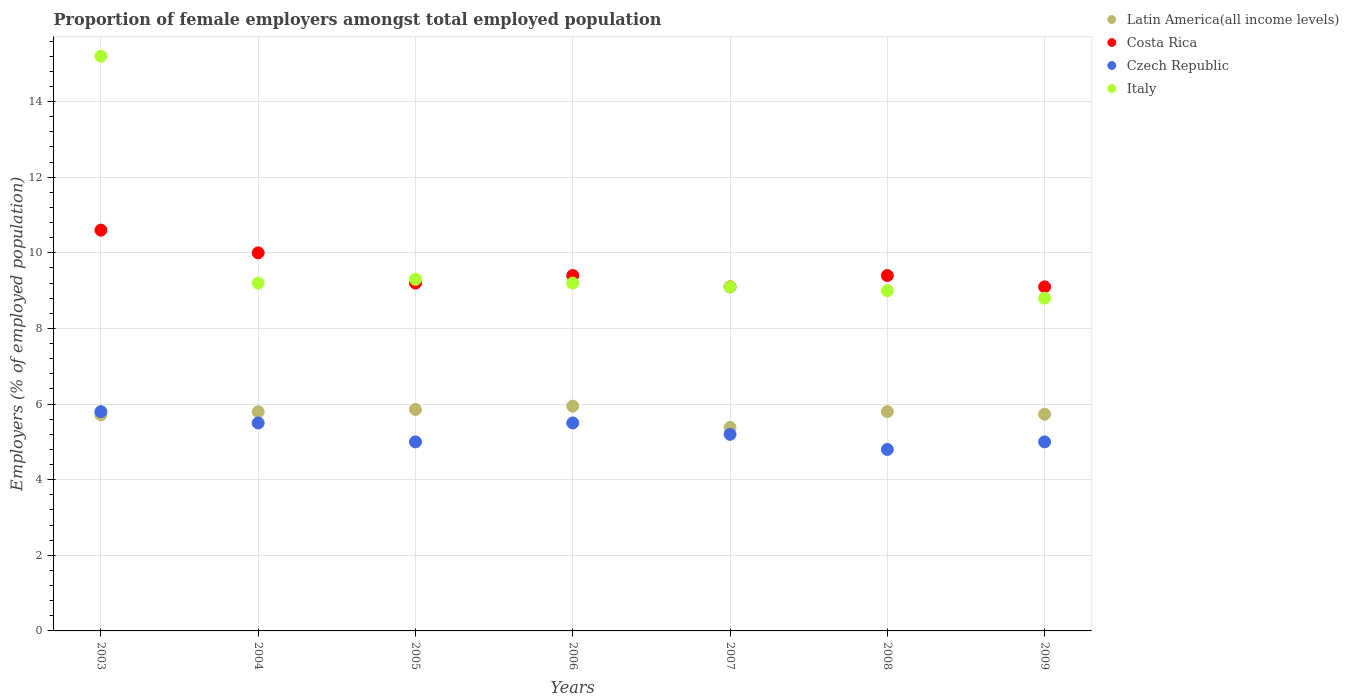How many different coloured dotlines are there?
Your answer should be compact. 4. Across all years, what is the maximum proportion of female employers in Czech Republic?
Offer a terse response. 5.8. Across all years, what is the minimum proportion of female employers in Costa Rica?
Your response must be concise. 9.1. In which year was the proportion of female employers in Costa Rica maximum?
Offer a terse response. 2003. In which year was the proportion of female employers in Latin America(all income levels) minimum?
Offer a very short reply. 2007. What is the total proportion of female employers in Costa Rica in the graph?
Offer a terse response. 66.8. What is the difference between the proportion of female employers in Costa Rica in 2006 and that in 2008?
Provide a short and direct response. 0. What is the difference between the proportion of female employers in Italy in 2004 and the proportion of female employers in Czech Republic in 2008?
Offer a very short reply. 4.4. What is the average proportion of female employers in Czech Republic per year?
Offer a terse response. 5.26. In the year 2007, what is the difference between the proportion of female employers in Italy and proportion of female employers in Costa Rica?
Give a very brief answer. 0. In how many years, is the proportion of female employers in Italy greater than 2.4 %?
Make the answer very short. 7. What is the ratio of the proportion of female employers in Latin America(all income levels) in 2004 to that in 2009?
Keep it short and to the point. 1.01. Is the proportion of female employers in Czech Republic in 2003 less than that in 2004?
Give a very brief answer. No. Is the difference between the proportion of female employers in Italy in 2004 and 2005 greater than the difference between the proportion of female employers in Costa Rica in 2004 and 2005?
Offer a very short reply. No. What is the difference between the highest and the second highest proportion of female employers in Italy?
Keep it short and to the point. 5.9. What is the difference between the highest and the lowest proportion of female employers in Costa Rica?
Ensure brevity in your answer.  1.5. In how many years, is the proportion of female employers in Italy greater than the average proportion of female employers in Italy taken over all years?
Ensure brevity in your answer.  1. Is the sum of the proportion of female employers in Costa Rica in 2004 and 2009 greater than the maximum proportion of female employers in Latin America(all income levels) across all years?
Make the answer very short. Yes. Is it the case that in every year, the sum of the proportion of female employers in Latin America(all income levels) and proportion of female employers in Czech Republic  is greater than the sum of proportion of female employers in Italy and proportion of female employers in Costa Rica?
Provide a short and direct response. No. Is it the case that in every year, the sum of the proportion of female employers in Latin America(all income levels) and proportion of female employers in Czech Republic  is greater than the proportion of female employers in Costa Rica?
Offer a terse response. Yes. Does the proportion of female employers in Italy monotonically increase over the years?
Offer a terse response. No. Is the proportion of female employers in Italy strictly greater than the proportion of female employers in Costa Rica over the years?
Offer a terse response. No. What is the difference between two consecutive major ticks on the Y-axis?
Offer a terse response. 2. Does the graph contain grids?
Make the answer very short. Yes. Where does the legend appear in the graph?
Give a very brief answer. Top right. What is the title of the graph?
Give a very brief answer. Proportion of female employers amongst total employed population. What is the label or title of the X-axis?
Your answer should be very brief. Years. What is the label or title of the Y-axis?
Ensure brevity in your answer.  Employers (% of employed population). What is the Employers (% of employed population) in Latin America(all income levels) in 2003?
Keep it short and to the point. 5.72. What is the Employers (% of employed population) in Costa Rica in 2003?
Your response must be concise. 10.6. What is the Employers (% of employed population) of Czech Republic in 2003?
Your answer should be very brief. 5.8. What is the Employers (% of employed population) in Italy in 2003?
Offer a very short reply. 15.2. What is the Employers (% of employed population) in Latin America(all income levels) in 2004?
Provide a short and direct response. 5.8. What is the Employers (% of employed population) in Costa Rica in 2004?
Offer a very short reply. 10. What is the Employers (% of employed population) in Italy in 2004?
Provide a short and direct response. 9.2. What is the Employers (% of employed population) of Latin America(all income levels) in 2005?
Offer a very short reply. 5.86. What is the Employers (% of employed population) in Costa Rica in 2005?
Your answer should be very brief. 9.2. What is the Employers (% of employed population) in Italy in 2005?
Your response must be concise. 9.3. What is the Employers (% of employed population) in Latin America(all income levels) in 2006?
Your answer should be compact. 5.95. What is the Employers (% of employed population) in Costa Rica in 2006?
Your response must be concise. 9.4. What is the Employers (% of employed population) of Czech Republic in 2006?
Give a very brief answer. 5.5. What is the Employers (% of employed population) of Italy in 2006?
Offer a terse response. 9.2. What is the Employers (% of employed population) in Latin America(all income levels) in 2007?
Your answer should be very brief. 5.38. What is the Employers (% of employed population) of Costa Rica in 2007?
Offer a very short reply. 9.1. What is the Employers (% of employed population) of Czech Republic in 2007?
Your response must be concise. 5.2. What is the Employers (% of employed population) in Italy in 2007?
Your answer should be very brief. 9.1. What is the Employers (% of employed population) in Latin America(all income levels) in 2008?
Provide a succinct answer. 5.8. What is the Employers (% of employed population) in Costa Rica in 2008?
Your answer should be very brief. 9.4. What is the Employers (% of employed population) in Czech Republic in 2008?
Offer a terse response. 4.8. What is the Employers (% of employed population) in Latin America(all income levels) in 2009?
Make the answer very short. 5.73. What is the Employers (% of employed population) in Costa Rica in 2009?
Make the answer very short. 9.1. What is the Employers (% of employed population) of Italy in 2009?
Offer a terse response. 8.8. Across all years, what is the maximum Employers (% of employed population) of Latin America(all income levels)?
Keep it short and to the point. 5.95. Across all years, what is the maximum Employers (% of employed population) in Costa Rica?
Your answer should be very brief. 10.6. Across all years, what is the maximum Employers (% of employed population) in Czech Republic?
Your answer should be very brief. 5.8. Across all years, what is the maximum Employers (% of employed population) in Italy?
Offer a terse response. 15.2. Across all years, what is the minimum Employers (% of employed population) of Latin America(all income levels)?
Keep it short and to the point. 5.38. Across all years, what is the minimum Employers (% of employed population) in Costa Rica?
Your answer should be compact. 9.1. Across all years, what is the minimum Employers (% of employed population) of Czech Republic?
Give a very brief answer. 4.8. Across all years, what is the minimum Employers (% of employed population) in Italy?
Your answer should be very brief. 8.8. What is the total Employers (% of employed population) in Latin America(all income levels) in the graph?
Offer a very short reply. 40.23. What is the total Employers (% of employed population) in Costa Rica in the graph?
Your response must be concise. 66.8. What is the total Employers (% of employed population) in Czech Republic in the graph?
Your answer should be compact. 36.8. What is the total Employers (% of employed population) of Italy in the graph?
Offer a very short reply. 69.8. What is the difference between the Employers (% of employed population) of Latin America(all income levels) in 2003 and that in 2004?
Ensure brevity in your answer.  -0.08. What is the difference between the Employers (% of employed population) in Costa Rica in 2003 and that in 2004?
Your answer should be compact. 0.6. What is the difference between the Employers (% of employed population) in Latin America(all income levels) in 2003 and that in 2005?
Keep it short and to the point. -0.14. What is the difference between the Employers (% of employed population) in Italy in 2003 and that in 2005?
Make the answer very short. 5.9. What is the difference between the Employers (% of employed population) in Latin America(all income levels) in 2003 and that in 2006?
Your response must be concise. -0.23. What is the difference between the Employers (% of employed population) in Latin America(all income levels) in 2003 and that in 2007?
Your response must be concise. 0.33. What is the difference between the Employers (% of employed population) of Costa Rica in 2003 and that in 2007?
Ensure brevity in your answer.  1.5. What is the difference between the Employers (% of employed population) in Czech Republic in 2003 and that in 2007?
Provide a succinct answer. 0.6. What is the difference between the Employers (% of employed population) of Italy in 2003 and that in 2007?
Give a very brief answer. 6.1. What is the difference between the Employers (% of employed population) of Latin America(all income levels) in 2003 and that in 2008?
Give a very brief answer. -0.08. What is the difference between the Employers (% of employed population) in Czech Republic in 2003 and that in 2008?
Make the answer very short. 1. What is the difference between the Employers (% of employed population) in Italy in 2003 and that in 2008?
Provide a succinct answer. 6.2. What is the difference between the Employers (% of employed population) of Latin America(all income levels) in 2003 and that in 2009?
Offer a very short reply. -0.02. What is the difference between the Employers (% of employed population) of Costa Rica in 2003 and that in 2009?
Your answer should be compact. 1.5. What is the difference between the Employers (% of employed population) of Latin America(all income levels) in 2004 and that in 2005?
Your response must be concise. -0.06. What is the difference between the Employers (% of employed population) of Costa Rica in 2004 and that in 2005?
Keep it short and to the point. 0.8. What is the difference between the Employers (% of employed population) in Latin America(all income levels) in 2004 and that in 2006?
Make the answer very short. -0.15. What is the difference between the Employers (% of employed population) of Costa Rica in 2004 and that in 2006?
Ensure brevity in your answer.  0.6. What is the difference between the Employers (% of employed population) in Latin America(all income levels) in 2004 and that in 2007?
Your answer should be compact. 0.41. What is the difference between the Employers (% of employed population) of Costa Rica in 2004 and that in 2007?
Offer a terse response. 0.9. What is the difference between the Employers (% of employed population) of Latin America(all income levels) in 2004 and that in 2008?
Make the answer very short. -0. What is the difference between the Employers (% of employed population) in Czech Republic in 2004 and that in 2008?
Provide a succinct answer. 0.7. What is the difference between the Employers (% of employed population) in Italy in 2004 and that in 2008?
Ensure brevity in your answer.  0.2. What is the difference between the Employers (% of employed population) of Latin America(all income levels) in 2004 and that in 2009?
Keep it short and to the point. 0.06. What is the difference between the Employers (% of employed population) of Latin America(all income levels) in 2005 and that in 2006?
Give a very brief answer. -0.09. What is the difference between the Employers (% of employed population) in Costa Rica in 2005 and that in 2006?
Offer a very short reply. -0.2. What is the difference between the Employers (% of employed population) in Czech Republic in 2005 and that in 2006?
Ensure brevity in your answer.  -0.5. What is the difference between the Employers (% of employed population) in Italy in 2005 and that in 2006?
Offer a very short reply. 0.1. What is the difference between the Employers (% of employed population) in Latin America(all income levels) in 2005 and that in 2007?
Ensure brevity in your answer.  0.48. What is the difference between the Employers (% of employed population) of Czech Republic in 2005 and that in 2007?
Your answer should be very brief. -0.2. What is the difference between the Employers (% of employed population) of Latin America(all income levels) in 2005 and that in 2008?
Give a very brief answer. 0.06. What is the difference between the Employers (% of employed population) of Costa Rica in 2005 and that in 2008?
Provide a succinct answer. -0.2. What is the difference between the Employers (% of employed population) in Latin America(all income levels) in 2005 and that in 2009?
Make the answer very short. 0.13. What is the difference between the Employers (% of employed population) in Costa Rica in 2005 and that in 2009?
Offer a terse response. 0.1. What is the difference between the Employers (% of employed population) of Latin America(all income levels) in 2006 and that in 2007?
Give a very brief answer. 0.56. What is the difference between the Employers (% of employed population) in Latin America(all income levels) in 2006 and that in 2008?
Offer a very short reply. 0.14. What is the difference between the Employers (% of employed population) in Costa Rica in 2006 and that in 2008?
Offer a very short reply. 0. What is the difference between the Employers (% of employed population) of Czech Republic in 2006 and that in 2008?
Ensure brevity in your answer.  0.7. What is the difference between the Employers (% of employed population) of Italy in 2006 and that in 2008?
Provide a succinct answer. 0.2. What is the difference between the Employers (% of employed population) in Latin America(all income levels) in 2006 and that in 2009?
Provide a short and direct response. 0.21. What is the difference between the Employers (% of employed population) of Costa Rica in 2006 and that in 2009?
Offer a very short reply. 0.3. What is the difference between the Employers (% of employed population) of Czech Republic in 2006 and that in 2009?
Make the answer very short. 0.5. What is the difference between the Employers (% of employed population) in Italy in 2006 and that in 2009?
Your answer should be very brief. 0.4. What is the difference between the Employers (% of employed population) in Latin America(all income levels) in 2007 and that in 2008?
Make the answer very short. -0.42. What is the difference between the Employers (% of employed population) in Latin America(all income levels) in 2007 and that in 2009?
Make the answer very short. -0.35. What is the difference between the Employers (% of employed population) in Italy in 2007 and that in 2009?
Your response must be concise. 0.3. What is the difference between the Employers (% of employed population) of Latin America(all income levels) in 2008 and that in 2009?
Provide a short and direct response. 0.07. What is the difference between the Employers (% of employed population) in Costa Rica in 2008 and that in 2009?
Give a very brief answer. 0.3. What is the difference between the Employers (% of employed population) of Czech Republic in 2008 and that in 2009?
Ensure brevity in your answer.  -0.2. What is the difference between the Employers (% of employed population) in Italy in 2008 and that in 2009?
Provide a succinct answer. 0.2. What is the difference between the Employers (% of employed population) in Latin America(all income levels) in 2003 and the Employers (% of employed population) in Costa Rica in 2004?
Offer a very short reply. -4.28. What is the difference between the Employers (% of employed population) of Latin America(all income levels) in 2003 and the Employers (% of employed population) of Czech Republic in 2004?
Ensure brevity in your answer.  0.22. What is the difference between the Employers (% of employed population) in Latin America(all income levels) in 2003 and the Employers (% of employed population) in Italy in 2004?
Keep it short and to the point. -3.48. What is the difference between the Employers (% of employed population) of Costa Rica in 2003 and the Employers (% of employed population) of Italy in 2004?
Offer a terse response. 1.4. What is the difference between the Employers (% of employed population) of Latin America(all income levels) in 2003 and the Employers (% of employed population) of Costa Rica in 2005?
Your response must be concise. -3.48. What is the difference between the Employers (% of employed population) of Latin America(all income levels) in 2003 and the Employers (% of employed population) of Czech Republic in 2005?
Offer a terse response. 0.72. What is the difference between the Employers (% of employed population) of Latin America(all income levels) in 2003 and the Employers (% of employed population) of Italy in 2005?
Your response must be concise. -3.58. What is the difference between the Employers (% of employed population) of Czech Republic in 2003 and the Employers (% of employed population) of Italy in 2005?
Offer a very short reply. -3.5. What is the difference between the Employers (% of employed population) of Latin America(all income levels) in 2003 and the Employers (% of employed population) of Costa Rica in 2006?
Give a very brief answer. -3.68. What is the difference between the Employers (% of employed population) of Latin America(all income levels) in 2003 and the Employers (% of employed population) of Czech Republic in 2006?
Make the answer very short. 0.22. What is the difference between the Employers (% of employed population) in Latin America(all income levels) in 2003 and the Employers (% of employed population) in Italy in 2006?
Your response must be concise. -3.48. What is the difference between the Employers (% of employed population) in Costa Rica in 2003 and the Employers (% of employed population) in Czech Republic in 2006?
Provide a succinct answer. 5.1. What is the difference between the Employers (% of employed population) of Latin America(all income levels) in 2003 and the Employers (% of employed population) of Costa Rica in 2007?
Make the answer very short. -3.38. What is the difference between the Employers (% of employed population) of Latin America(all income levels) in 2003 and the Employers (% of employed population) of Czech Republic in 2007?
Your answer should be compact. 0.52. What is the difference between the Employers (% of employed population) of Latin America(all income levels) in 2003 and the Employers (% of employed population) of Italy in 2007?
Ensure brevity in your answer.  -3.38. What is the difference between the Employers (% of employed population) in Costa Rica in 2003 and the Employers (% of employed population) in Czech Republic in 2007?
Provide a short and direct response. 5.4. What is the difference between the Employers (% of employed population) of Latin America(all income levels) in 2003 and the Employers (% of employed population) of Costa Rica in 2008?
Ensure brevity in your answer.  -3.68. What is the difference between the Employers (% of employed population) in Latin America(all income levels) in 2003 and the Employers (% of employed population) in Czech Republic in 2008?
Offer a terse response. 0.92. What is the difference between the Employers (% of employed population) of Latin America(all income levels) in 2003 and the Employers (% of employed population) of Italy in 2008?
Your answer should be compact. -3.28. What is the difference between the Employers (% of employed population) in Costa Rica in 2003 and the Employers (% of employed population) in Italy in 2008?
Offer a terse response. 1.6. What is the difference between the Employers (% of employed population) of Czech Republic in 2003 and the Employers (% of employed population) of Italy in 2008?
Provide a succinct answer. -3.2. What is the difference between the Employers (% of employed population) in Latin America(all income levels) in 2003 and the Employers (% of employed population) in Costa Rica in 2009?
Your answer should be compact. -3.38. What is the difference between the Employers (% of employed population) of Latin America(all income levels) in 2003 and the Employers (% of employed population) of Czech Republic in 2009?
Give a very brief answer. 0.72. What is the difference between the Employers (% of employed population) in Latin America(all income levels) in 2003 and the Employers (% of employed population) in Italy in 2009?
Provide a succinct answer. -3.08. What is the difference between the Employers (% of employed population) in Costa Rica in 2003 and the Employers (% of employed population) in Italy in 2009?
Provide a short and direct response. 1.8. What is the difference between the Employers (% of employed population) in Latin America(all income levels) in 2004 and the Employers (% of employed population) in Costa Rica in 2005?
Offer a very short reply. -3.4. What is the difference between the Employers (% of employed population) in Latin America(all income levels) in 2004 and the Employers (% of employed population) in Czech Republic in 2005?
Keep it short and to the point. 0.8. What is the difference between the Employers (% of employed population) in Latin America(all income levels) in 2004 and the Employers (% of employed population) in Italy in 2005?
Keep it short and to the point. -3.5. What is the difference between the Employers (% of employed population) in Czech Republic in 2004 and the Employers (% of employed population) in Italy in 2005?
Ensure brevity in your answer.  -3.8. What is the difference between the Employers (% of employed population) in Latin America(all income levels) in 2004 and the Employers (% of employed population) in Costa Rica in 2006?
Offer a terse response. -3.6. What is the difference between the Employers (% of employed population) of Latin America(all income levels) in 2004 and the Employers (% of employed population) of Czech Republic in 2006?
Keep it short and to the point. 0.3. What is the difference between the Employers (% of employed population) in Latin America(all income levels) in 2004 and the Employers (% of employed population) in Italy in 2006?
Offer a very short reply. -3.4. What is the difference between the Employers (% of employed population) in Latin America(all income levels) in 2004 and the Employers (% of employed population) in Costa Rica in 2007?
Offer a very short reply. -3.3. What is the difference between the Employers (% of employed population) in Latin America(all income levels) in 2004 and the Employers (% of employed population) in Czech Republic in 2007?
Ensure brevity in your answer.  0.6. What is the difference between the Employers (% of employed population) of Latin America(all income levels) in 2004 and the Employers (% of employed population) of Italy in 2007?
Offer a very short reply. -3.3. What is the difference between the Employers (% of employed population) of Costa Rica in 2004 and the Employers (% of employed population) of Italy in 2007?
Provide a succinct answer. 0.9. What is the difference between the Employers (% of employed population) in Latin America(all income levels) in 2004 and the Employers (% of employed population) in Costa Rica in 2008?
Your answer should be compact. -3.6. What is the difference between the Employers (% of employed population) of Latin America(all income levels) in 2004 and the Employers (% of employed population) of Italy in 2008?
Offer a terse response. -3.2. What is the difference between the Employers (% of employed population) of Costa Rica in 2004 and the Employers (% of employed population) of Italy in 2008?
Your response must be concise. 1. What is the difference between the Employers (% of employed population) of Czech Republic in 2004 and the Employers (% of employed population) of Italy in 2008?
Keep it short and to the point. -3.5. What is the difference between the Employers (% of employed population) in Latin America(all income levels) in 2004 and the Employers (% of employed population) in Costa Rica in 2009?
Ensure brevity in your answer.  -3.3. What is the difference between the Employers (% of employed population) in Latin America(all income levels) in 2004 and the Employers (% of employed population) in Czech Republic in 2009?
Provide a succinct answer. 0.8. What is the difference between the Employers (% of employed population) of Latin America(all income levels) in 2004 and the Employers (% of employed population) of Italy in 2009?
Keep it short and to the point. -3. What is the difference between the Employers (% of employed population) in Costa Rica in 2004 and the Employers (% of employed population) in Czech Republic in 2009?
Offer a very short reply. 5. What is the difference between the Employers (% of employed population) in Costa Rica in 2004 and the Employers (% of employed population) in Italy in 2009?
Offer a terse response. 1.2. What is the difference between the Employers (% of employed population) in Czech Republic in 2004 and the Employers (% of employed population) in Italy in 2009?
Ensure brevity in your answer.  -3.3. What is the difference between the Employers (% of employed population) of Latin America(all income levels) in 2005 and the Employers (% of employed population) of Costa Rica in 2006?
Keep it short and to the point. -3.54. What is the difference between the Employers (% of employed population) of Latin America(all income levels) in 2005 and the Employers (% of employed population) of Czech Republic in 2006?
Your answer should be very brief. 0.36. What is the difference between the Employers (% of employed population) in Latin America(all income levels) in 2005 and the Employers (% of employed population) in Italy in 2006?
Provide a short and direct response. -3.34. What is the difference between the Employers (% of employed population) of Costa Rica in 2005 and the Employers (% of employed population) of Czech Republic in 2006?
Provide a succinct answer. 3.7. What is the difference between the Employers (% of employed population) in Costa Rica in 2005 and the Employers (% of employed population) in Italy in 2006?
Make the answer very short. 0. What is the difference between the Employers (% of employed population) of Czech Republic in 2005 and the Employers (% of employed population) of Italy in 2006?
Your response must be concise. -4.2. What is the difference between the Employers (% of employed population) in Latin America(all income levels) in 2005 and the Employers (% of employed population) in Costa Rica in 2007?
Your answer should be very brief. -3.24. What is the difference between the Employers (% of employed population) in Latin America(all income levels) in 2005 and the Employers (% of employed population) in Czech Republic in 2007?
Offer a terse response. 0.66. What is the difference between the Employers (% of employed population) in Latin America(all income levels) in 2005 and the Employers (% of employed population) in Italy in 2007?
Offer a terse response. -3.24. What is the difference between the Employers (% of employed population) in Latin America(all income levels) in 2005 and the Employers (% of employed population) in Costa Rica in 2008?
Provide a short and direct response. -3.54. What is the difference between the Employers (% of employed population) of Latin America(all income levels) in 2005 and the Employers (% of employed population) of Czech Republic in 2008?
Offer a very short reply. 1.06. What is the difference between the Employers (% of employed population) in Latin America(all income levels) in 2005 and the Employers (% of employed population) in Italy in 2008?
Make the answer very short. -3.14. What is the difference between the Employers (% of employed population) in Costa Rica in 2005 and the Employers (% of employed population) in Czech Republic in 2008?
Keep it short and to the point. 4.4. What is the difference between the Employers (% of employed population) of Latin America(all income levels) in 2005 and the Employers (% of employed population) of Costa Rica in 2009?
Keep it short and to the point. -3.24. What is the difference between the Employers (% of employed population) of Latin America(all income levels) in 2005 and the Employers (% of employed population) of Czech Republic in 2009?
Your response must be concise. 0.86. What is the difference between the Employers (% of employed population) in Latin America(all income levels) in 2005 and the Employers (% of employed population) in Italy in 2009?
Provide a short and direct response. -2.94. What is the difference between the Employers (% of employed population) of Costa Rica in 2005 and the Employers (% of employed population) of Czech Republic in 2009?
Give a very brief answer. 4.2. What is the difference between the Employers (% of employed population) of Latin America(all income levels) in 2006 and the Employers (% of employed population) of Costa Rica in 2007?
Offer a very short reply. -3.15. What is the difference between the Employers (% of employed population) in Latin America(all income levels) in 2006 and the Employers (% of employed population) in Czech Republic in 2007?
Ensure brevity in your answer.  0.75. What is the difference between the Employers (% of employed population) of Latin America(all income levels) in 2006 and the Employers (% of employed population) of Italy in 2007?
Your response must be concise. -3.15. What is the difference between the Employers (% of employed population) of Czech Republic in 2006 and the Employers (% of employed population) of Italy in 2007?
Provide a short and direct response. -3.6. What is the difference between the Employers (% of employed population) in Latin America(all income levels) in 2006 and the Employers (% of employed population) in Costa Rica in 2008?
Ensure brevity in your answer.  -3.45. What is the difference between the Employers (% of employed population) in Latin America(all income levels) in 2006 and the Employers (% of employed population) in Czech Republic in 2008?
Keep it short and to the point. 1.15. What is the difference between the Employers (% of employed population) in Latin America(all income levels) in 2006 and the Employers (% of employed population) in Italy in 2008?
Keep it short and to the point. -3.05. What is the difference between the Employers (% of employed population) of Costa Rica in 2006 and the Employers (% of employed population) of Czech Republic in 2008?
Provide a short and direct response. 4.6. What is the difference between the Employers (% of employed population) in Latin America(all income levels) in 2006 and the Employers (% of employed population) in Costa Rica in 2009?
Provide a short and direct response. -3.15. What is the difference between the Employers (% of employed population) of Latin America(all income levels) in 2006 and the Employers (% of employed population) of Czech Republic in 2009?
Offer a very short reply. 0.95. What is the difference between the Employers (% of employed population) in Latin America(all income levels) in 2006 and the Employers (% of employed population) in Italy in 2009?
Provide a succinct answer. -2.85. What is the difference between the Employers (% of employed population) in Costa Rica in 2006 and the Employers (% of employed population) in Czech Republic in 2009?
Ensure brevity in your answer.  4.4. What is the difference between the Employers (% of employed population) of Latin America(all income levels) in 2007 and the Employers (% of employed population) of Costa Rica in 2008?
Provide a short and direct response. -4.02. What is the difference between the Employers (% of employed population) of Latin America(all income levels) in 2007 and the Employers (% of employed population) of Czech Republic in 2008?
Offer a terse response. 0.58. What is the difference between the Employers (% of employed population) in Latin America(all income levels) in 2007 and the Employers (% of employed population) in Italy in 2008?
Offer a very short reply. -3.62. What is the difference between the Employers (% of employed population) in Costa Rica in 2007 and the Employers (% of employed population) in Czech Republic in 2008?
Provide a succinct answer. 4.3. What is the difference between the Employers (% of employed population) in Costa Rica in 2007 and the Employers (% of employed population) in Italy in 2008?
Offer a terse response. 0.1. What is the difference between the Employers (% of employed population) in Czech Republic in 2007 and the Employers (% of employed population) in Italy in 2008?
Your answer should be compact. -3.8. What is the difference between the Employers (% of employed population) in Latin America(all income levels) in 2007 and the Employers (% of employed population) in Costa Rica in 2009?
Your response must be concise. -3.72. What is the difference between the Employers (% of employed population) in Latin America(all income levels) in 2007 and the Employers (% of employed population) in Czech Republic in 2009?
Make the answer very short. 0.38. What is the difference between the Employers (% of employed population) of Latin America(all income levels) in 2007 and the Employers (% of employed population) of Italy in 2009?
Your response must be concise. -3.42. What is the difference between the Employers (% of employed population) of Costa Rica in 2007 and the Employers (% of employed population) of Italy in 2009?
Your answer should be compact. 0.3. What is the difference between the Employers (% of employed population) of Czech Republic in 2007 and the Employers (% of employed population) of Italy in 2009?
Provide a short and direct response. -3.6. What is the difference between the Employers (% of employed population) of Latin America(all income levels) in 2008 and the Employers (% of employed population) of Costa Rica in 2009?
Offer a terse response. -3.3. What is the difference between the Employers (% of employed population) in Latin America(all income levels) in 2008 and the Employers (% of employed population) in Czech Republic in 2009?
Offer a terse response. 0.8. What is the difference between the Employers (% of employed population) of Latin America(all income levels) in 2008 and the Employers (% of employed population) of Italy in 2009?
Provide a short and direct response. -3. What is the difference between the Employers (% of employed population) in Costa Rica in 2008 and the Employers (% of employed population) in Czech Republic in 2009?
Offer a very short reply. 4.4. What is the difference between the Employers (% of employed population) of Costa Rica in 2008 and the Employers (% of employed population) of Italy in 2009?
Your answer should be compact. 0.6. What is the difference between the Employers (% of employed population) of Czech Republic in 2008 and the Employers (% of employed population) of Italy in 2009?
Provide a succinct answer. -4. What is the average Employers (% of employed population) in Latin America(all income levels) per year?
Provide a short and direct response. 5.75. What is the average Employers (% of employed population) of Costa Rica per year?
Your answer should be compact. 9.54. What is the average Employers (% of employed population) of Czech Republic per year?
Your answer should be very brief. 5.26. What is the average Employers (% of employed population) in Italy per year?
Ensure brevity in your answer.  9.97. In the year 2003, what is the difference between the Employers (% of employed population) of Latin America(all income levels) and Employers (% of employed population) of Costa Rica?
Your answer should be compact. -4.88. In the year 2003, what is the difference between the Employers (% of employed population) of Latin America(all income levels) and Employers (% of employed population) of Czech Republic?
Your answer should be very brief. -0.08. In the year 2003, what is the difference between the Employers (% of employed population) in Latin America(all income levels) and Employers (% of employed population) in Italy?
Give a very brief answer. -9.48. In the year 2003, what is the difference between the Employers (% of employed population) in Costa Rica and Employers (% of employed population) in Czech Republic?
Your answer should be compact. 4.8. In the year 2003, what is the difference between the Employers (% of employed population) of Costa Rica and Employers (% of employed population) of Italy?
Your answer should be compact. -4.6. In the year 2003, what is the difference between the Employers (% of employed population) of Czech Republic and Employers (% of employed population) of Italy?
Ensure brevity in your answer.  -9.4. In the year 2004, what is the difference between the Employers (% of employed population) in Latin America(all income levels) and Employers (% of employed population) in Costa Rica?
Keep it short and to the point. -4.2. In the year 2004, what is the difference between the Employers (% of employed population) of Latin America(all income levels) and Employers (% of employed population) of Czech Republic?
Provide a short and direct response. 0.3. In the year 2004, what is the difference between the Employers (% of employed population) of Latin America(all income levels) and Employers (% of employed population) of Italy?
Make the answer very short. -3.4. In the year 2004, what is the difference between the Employers (% of employed population) in Costa Rica and Employers (% of employed population) in Italy?
Your answer should be compact. 0.8. In the year 2005, what is the difference between the Employers (% of employed population) of Latin America(all income levels) and Employers (% of employed population) of Costa Rica?
Provide a short and direct response. -3.34. In the year 2005, what is the difference between the Employers (% of employed population) in Latin America(all income levels) and Employers (% of employed population) in Czech Republic?
Your response must be concise. 0.86. In the year 2005, what is the difference between the Employers (% of employed population) of Latin America(all income levels) and Employers (% of employed population) of Italy?
Provide a short and direct response. -3.44. In the year 2005, what is the difference between the Employers (% of employed population) in Costa Rica and Employers (% of employed population) in Czech Republic?
Your answer should be compact. 4.2. In the year 2005, what is the difference between the Employers (% of employed population) in Czech Republic and Employers (% of employed population) in Italy?
Your response must be concise. -4.3. In the year 2006, what is the difference between the Employers (% of employed population) in Latin America(all income levels) and Employers (% of employed population) in Costa Rica?
Offer a very short reply. -3.45. In the year 2006, what is the difference between the Employers (% of employed population) of Latin America(all income levels) and Employers (% of employed population) of Czech Republic?
Offer a very short reply. 0.45. In the year 2006, what is the difference between the Employers (% of employed population) of Latin America(all income levels) and Employers (% of employed population) of Italy?
Your response must be concise. -3.25. In the year 2006, what is the difference between the Employers (% of employed population) of Costa Rica and Employers (% of employed population) of Czech Republic?
Offer a very short reply. 3.9. In the year 2007, what is the difference between the Employers (% of employed population) of Latin America(all income levels) and Employers (% of employed population) of Costa Rica?
Ensure brevity in your answer.  -3.72. In the year 2007, what is the difference between the Employers (% of employed population) of Latin America(all income levels) and Employers (% of employed population) of Czech Republic?
Keep it short and to the point. 0.18. In the year 2007, what is the difference between the Employers (% of employed population) in Latin America(all income levels) and Employers (% of employed population) in Italy?
Keep it short and to the point. -3.72. In the year 2007, what is the difference between the Employers (% of employed population) in Czech Republic and Employers (% of employed population) in Italy?
Ensure brevity in your answer.  -3.9. In the year 2008, what is the difference between the Employers (% of employed population) in Latin America(all income levels) and Employers (% of employed population) in Costa Rica?
Give a very brief answer. -3.6. In the year 2008, what is the difference between the Employers (% of employed population) of Latin America(all income levels) and Employers (% of employed population) of Italy?
Your answer should be compact. -3.2. In the year 2008, what is the difference between the Employers (% of employed population) in Costa Rica and Employers (% of employed population) in Czech Republic?
Offer a terse response. 4.6. In the year 2008, what is the difference between the Employers (% of employed population) of Czech Republic and Employers (% of employed population) of Italy?
Keep it short and to the point. -4.2. In the year 2009, what is the difference between the Employers (% of employed population) in Latin America(all income levels) and Employers (% of employed population) in Costa Rica?
Your answer should be compact. -3.37. In the year 2009, what is the difference between the Employers (% of employed population) of Latin America(all income levels) and Employers (% of employed population) of Czech Republic?
Your answer should be compact. 0.73. In the year 2009, what is the difference between the Employers (% of employed population) of Latin America(all income levels) and Employers (% of employed population) of Italy?
Provide a succinct answer. -3.07. What is the ratio of the Employers (% of employed population) in Latin America(all income levels) in 2003 to that in 2004?
Provide a succinct answer. 0.99. What is the ratio of the Employers (% of employed population) in Costa Rica in 2003 to that in 2004?
Your response must be concise. 1.06. What is the ratio of the Employers (% of employed population) in Czech Republic in 2003 to that in 2004?
Your answer should be very brief. 1.05. What is the ratio of the Employers (% of employed population) of Italy in 2003 to that in 2004?
Your answer should be compact. 1.65. What is the ratio of the Employers (% of employed population) of Costa Rica in 2003 to that in 2005?
Ensure brevity in your answer.  1.15. What is the ratio of the Employers (% of employed population) of Czech Republic in 2003 to that in 2005?
Offer a terse response. 1.16. What is the ratio of the Employers (% of employed population) in Italy in 2003 to that in 2005?
Your response must be concise. 1.63. What is the ratio of the Employers (% of employed population) of Latin America(all income levels) in 2003 to that in 2006?
Offer a very short reply. 0.96. What is the ratio of the Employers (% of employed population) in Costa Rica in 2003 to that in 2006?
Keep it short and to the point. 1.13. What is the ratio of the Employers (% of employed population) of Czech Republic in 2003 to that in 2006?
Offer a very short reply. 1.05. What is the ratio of the Employers (% of employed population) in Italy in 2003 to that in 2006?
Your answer should be compact. 1.65. What is the ratio of the Employers (% of employed population) in Latin America(all income levels) in 2003 to that in 2007?
Keep it short and to the point. 1.06. What is the ratio of the Employers (% of employed population) in Costa Rica in 2003 to that in 2007?
Your response must be concise. 1.16. What is the ratio of the Employers (% of employed population) in Czech Republic in 2003 to that in 2007?
Provide a succinct answer. 1.12. What is the ratio of the Employers (% of employed population) in Italy in 2003 to that in 2007?
Provide a short and direct response. 1.67. What is the ratio of the Employers (% of employed population) in Latin America(all income levels) in 2003 to that in 2008?
Your answer should be very brief. 0.99. What is the ratio of the Employers (% of employed population) of Costa Rica in 2003 to that in 2008?
Make the answer very short. 1.13. What is the ratio of the Employers (% of employed population) of Czech Republic in 2003 to that in 2008?
Your response must be concise. 1.21. What is the ratio of the Employers (% of employed population) of Italy in 2003 to that in 2008?
Provide a short and direct response. 1.69. What is the ratio of the Employers (% of employed population) of Costa Rica in 2003 to that in 2009?
Ensure brevity in your answer.  1.16. What is the ratio of the Employers (% of employed population) of Czech Republic in 2003 to that in 2009?
Your response must be concise. 1.16. What is the ratio of the Employers (% of employed population) in Italy in 2003 to that in 2009?
Your answer should be very brief. 1.73. What is the ratio of the Employers (% of employed population) in Latin America(all income levels) in 2004 to that in 2005?
Your answer should be compact. 0.99. What is the ratio of the Employers (% of employed population) of Costa Rica in 2004 to that in 2005?
Ensure brevity in your answer.  1.09. What is the ratio of the Employers (% of employed population) of Latin America(all income levels) in 2004 to that in 2006?
Make the answer very short. 0.97. What is the ratio of the Employers (% of employed population) of Costa Rica in 2004 to that in 2006?
Give a very brief answer. 1.06. What is the ratio of the Employers (% of employed population) in Latin America(all income levels) in 2004 to that in 2007?
Your answer should be very brief. 1.08. What is the ratio of the Employers (% of employed population) in Costa Rica in 2004 to that in 2007?
Your answer should be compact. 1.1. What is the ratio of the Employers (% of employed population) of Czech Republic in 2004 to that in 2007?
Give a very brief answer. 1.06. What is the ratio of the Employers (% of employed population) in Costa Rica in 2004 to that in 2008?
Your answer should be compact. 1.06. What is the ratio of the Employers (% of employed population) in Czech Republic in 2004 to that in 2008?
Your response must be concise. 1.15. What is the ratio of the Employers (% of employed population) in Italy in 2004 to that in 2008?
Provide a short and direct response. 1.02. What is the ratio of the Employers (% of employed population) of Latin America(all income levels) in 2004 to that in 2009?
Your answer should be compact. 1.01. What is the ratio of the Employers (% of employed population) in Costa Rica in 2004 to that in 2009?
Offer a terse response. 1.1. What is the ratio of the Employers (% of employed population) in Czech Republic in 2004 to that in 2009?
Your response must be concise. 1.1. What is the ratio of the Employers (% of employed population) in Italy in 2004 to that in 2009?
Keep it short and to the point. 1.05. What is the ratio of the Employers (% of employed population) of Costa Rica in 2005 to that in 2006?
Give a very brief answer. 0.98. What is the ratio of the Employers (% of employed population) in Italy in 2005 to that in 2006?
Ensure brevity in your answer.  1.01. What is the ratio of the Employers (% of employed population) in Latin America(all income levels) in 2005 to that in 2007?
Make the answer very short. 1.09. What is the ratio of the Employers (% of employed population) in Costa Rica in 2005 to that in 2007?
Keep it short and to the point. 1.01. What is the ratio of the Employers (% of employed population) of Czech Republic in 2005 to that in 2007?
Provide a succinct answer. 0.96. What is the ratio of the Employers (% of employed population) of Italy in 2005 to that in 2007?
Give a very brief answer. 1.02. What is the ratio of the Employers (% of employed population) in Latin America(all income levels) in 2005 to that in 2008?
Keep it short and to the point. 1.01. What is the ratio of the Employers (% of employed population) of Costa Rica in 2005 to that in 2008?
Ensure brevity in your answer.  0.98. What is the ratio of the Employers (% of employed population) of Czech Republic in 2005 to that in 2008?
Ensure brevity in your answer.  1.04. What is the ratio of the Employers (% of employed population) of Latin America(all income levels) in 2005 to that in 2009?
Your answer should be compact. 1.02. What is the ratio of the Employers (% of employed population) in Costa Rica in 2005 to that in 2009?
Give a very brief answer. 1.01. What is the ratio of the Employers (% of employed population) in Czech Republic in 2005 to that in 2009?
Ensure brevity in your answer.  1. What is the ratio of the Employers (% of employed population) of Italy in 2005 to that in 2009?
Offer a terse response. 1.06. What is the ratio of the Employers (% of employed population) in Latin America(all income levels) in 2006 to that in 2007?
Keep it short and to the point. 1.1. What is the ratio of the Employers (% of employed population) in Costa Rica in 2006 to that in 2007?
Make the answer very short. 1.03. What is the ratio of the Employers (% of employed population) of Czech Republic in 2006 to that in 2007?
Your answer should be compact. 1.06. What is the ratio of the Employers (% of employed population) in Latin America(all income levels) in 2006 to that in 2008?
Your response must be concise. 1.02. What is the ratio of the Employers (% of employed population) in Costa Rica in 2006 to that in 2008?
Offer a very short reply. 1. What is the ratio of the Employers (% of employed population) in Czech Republic in 2006 to that in 2008?
Offer a terse response. 1.15. What is the ratio of the Employers (% of employed population) of Italy in 2006 to that in 2008?
Make the answer very short. 1.02. What is the ratio of the Employers (% of employed population) in Latin America(all income levels) in 2006 to that in 2009?
Give a very brief answer. 1.04. What is the ratio of the Employers (% of employed population) in Costa Rica in 2006 to that in 2009?
Ensure brevity in your answer.  1.03. What is the ratio of the Employers (% of employed population) of Czech Republic in 2006 to that in 2009?
Keep it short and to the point. 1.1. What is the ratio of the Employers (% of employed population) of Italy in 2006 to that in 2009?
Give a very brief answer. 1.05. What is the ratio of the Employers (% of employed population) in Latin America(all income levels) in 2007 to that in 2008?
Make the answer very short. 0.93. What is the ratio of the Employers (% of employed population) in Costa Rica in 2007 to that in 2008?
Provide a succinct answer. 0.97. What is the ratio of the Employers (% of employed population) in Italy in 2007 to that in 2008?
Your response must be concise. 1.01. What is the ratio of the Employers (% of employed population) in Latin America(all income levels) in 2007 to that in 2009?
Provide a succinct answer. 0.94. What is the ratio of the Employers (% of employed population) of Czech Republic in 2007 to that in 2009?
Your response must be concise. 1.04. What is the ratio of the Employers (% of employed population) in Italy in 2007 to that in 2009?
Your answer should be very brief. 1.03. What is the ratio of the Employers (% of employed population) of Latin America(all income levels) in 2008 to that in 2009?
Provide a short and direct response. 1.01. What is the ratio of the Employers (% of employed population) of Costa Rica in 2008 to that in 2009?
Your answer should be compact. 1.03. What is the ratio of the Employers (% of employed population) in Czech Republic in 2008 to that in 2009?
Offer a terse response. 0.96. What is the ratio of the Employers (% of employed population) of Italy in 2008 to that in 2009?
Give a very brief answer. 1.02. What is the difference between the highest and the second highest Employers (% of employed population) of Latin America(all income levels)?
Your response must be concise. 0.09. What is the difference between the highest and the second highest Employers (% of employed population) in Costa Rica?
Ensure brevity in your answer.  0.6. What is the difference between the highest and the second highest Employers (% of employed population) in Italy?
Ensure brevity in your answer.  5.9. What is the difference between the highest and the lowest Employers (% of employed population) of Latin America(all income levels)?
Keep it short and to the point. 0.56. What is the difference between the highest and the lowest Employers (% of employed population) of Italy?
Provide a short and direct response. 6.4. 